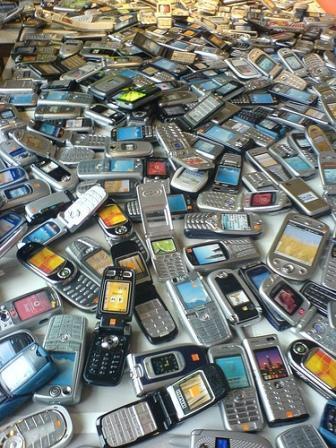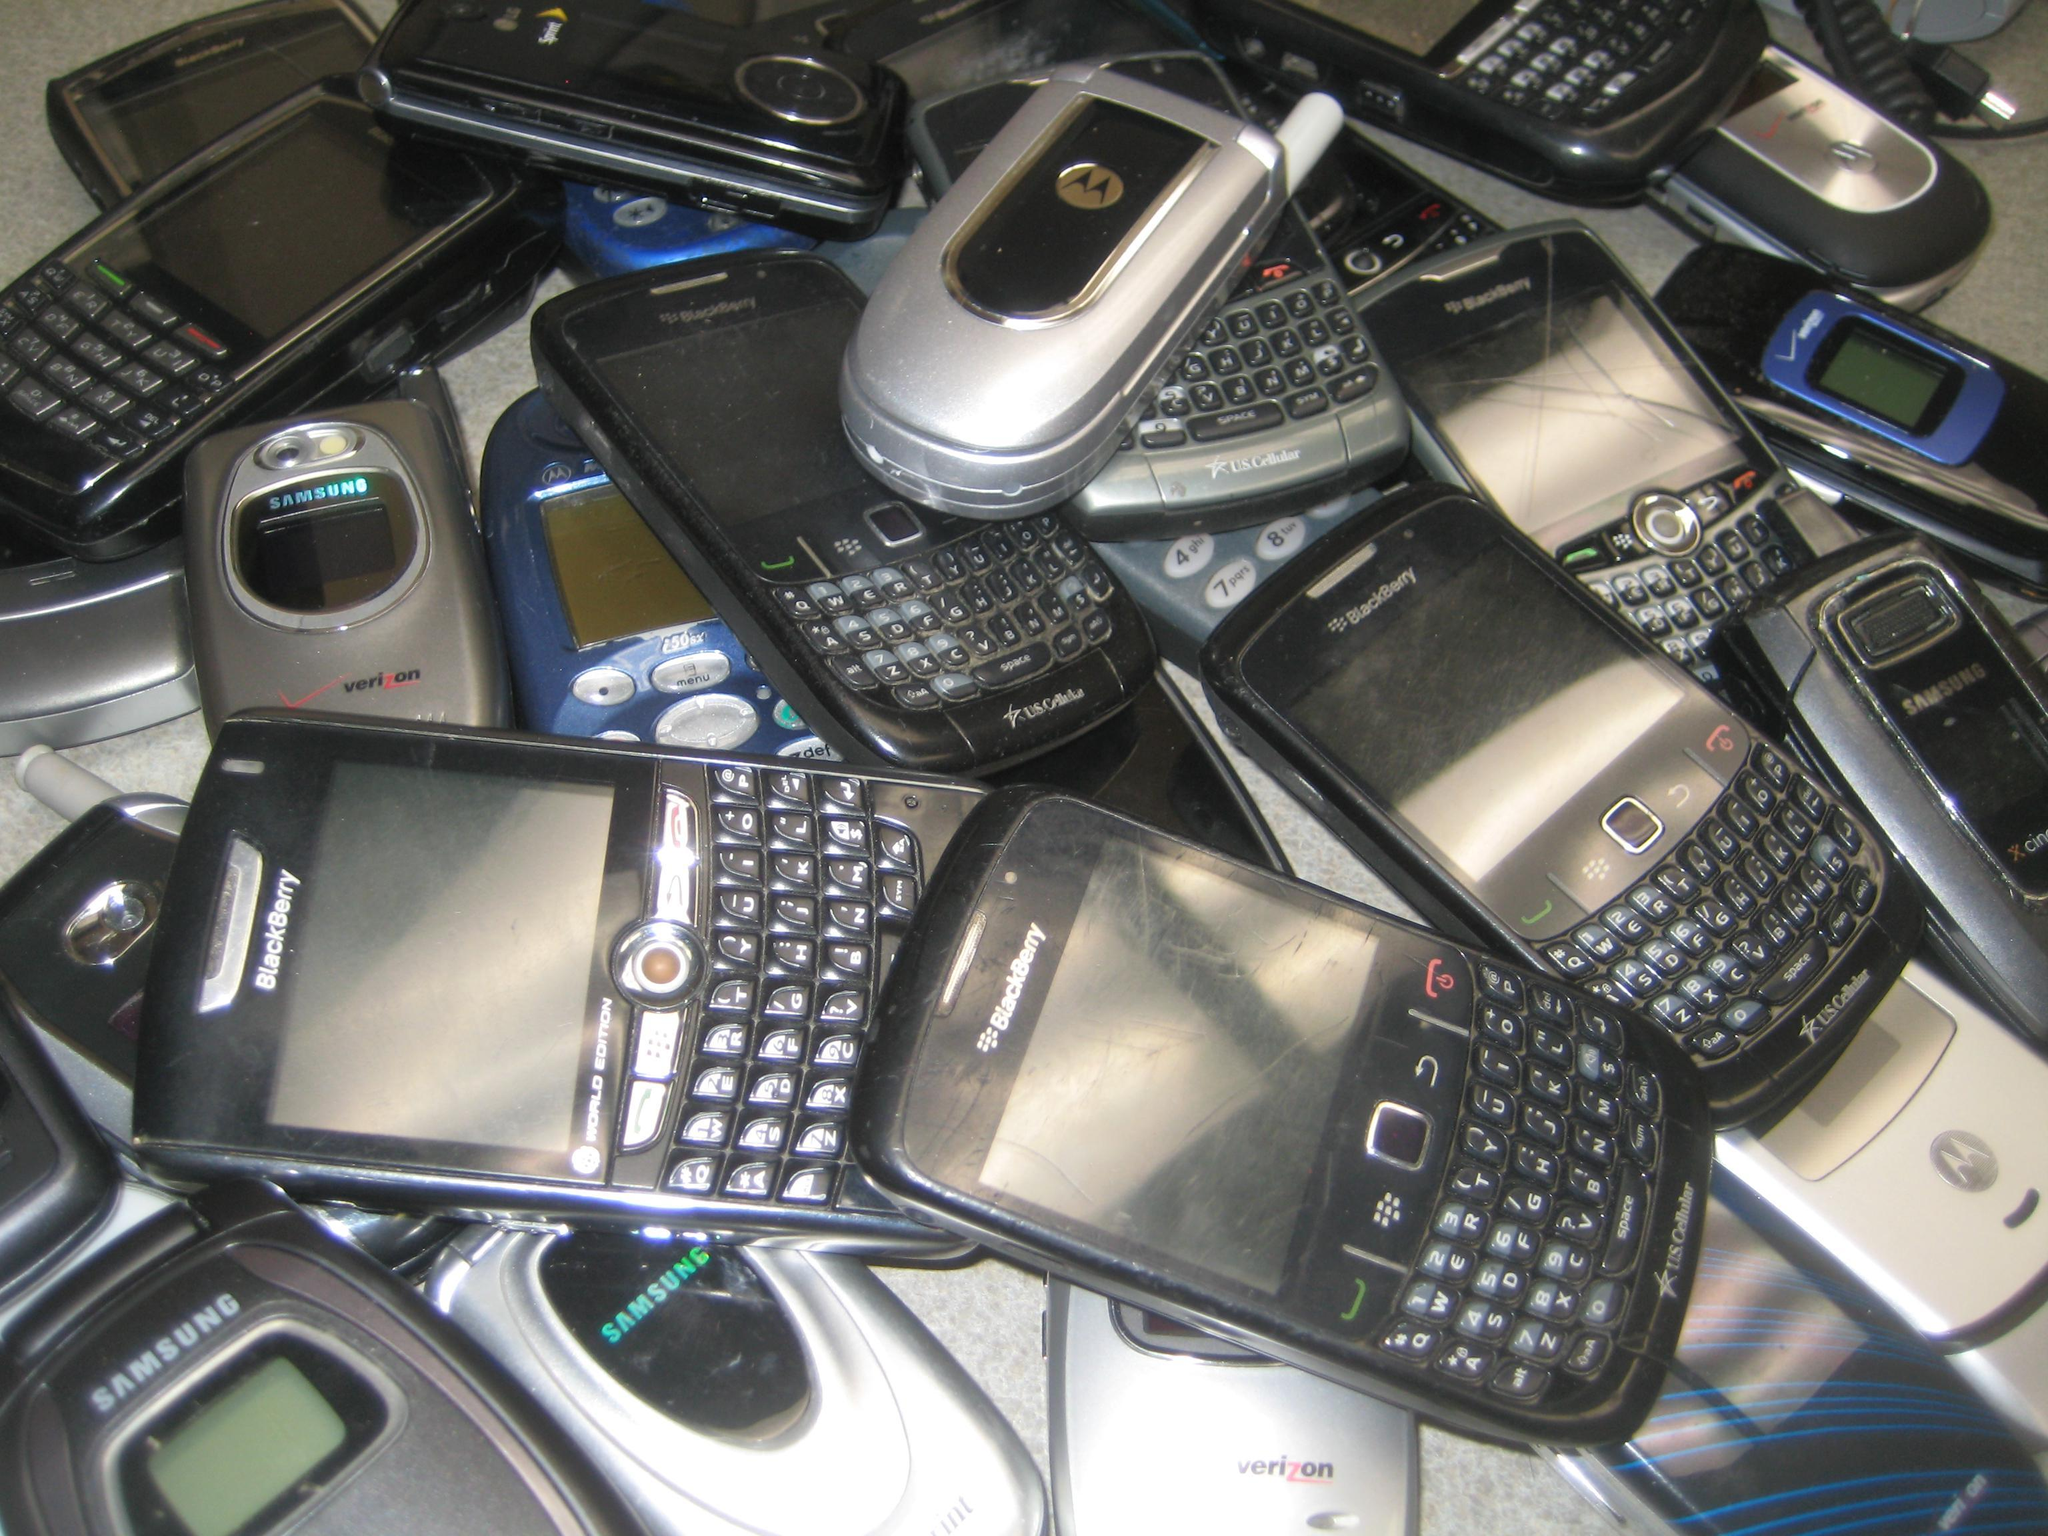The first image is the image on the left, the second image is the image on the right. Examine the images to the left and right. Is the description "The left image shows a pile of phones in a visible container with sides, and the right image shows a pile of phones - including at least two blue ones - with no container." accurate? Answer yes or no. No. 